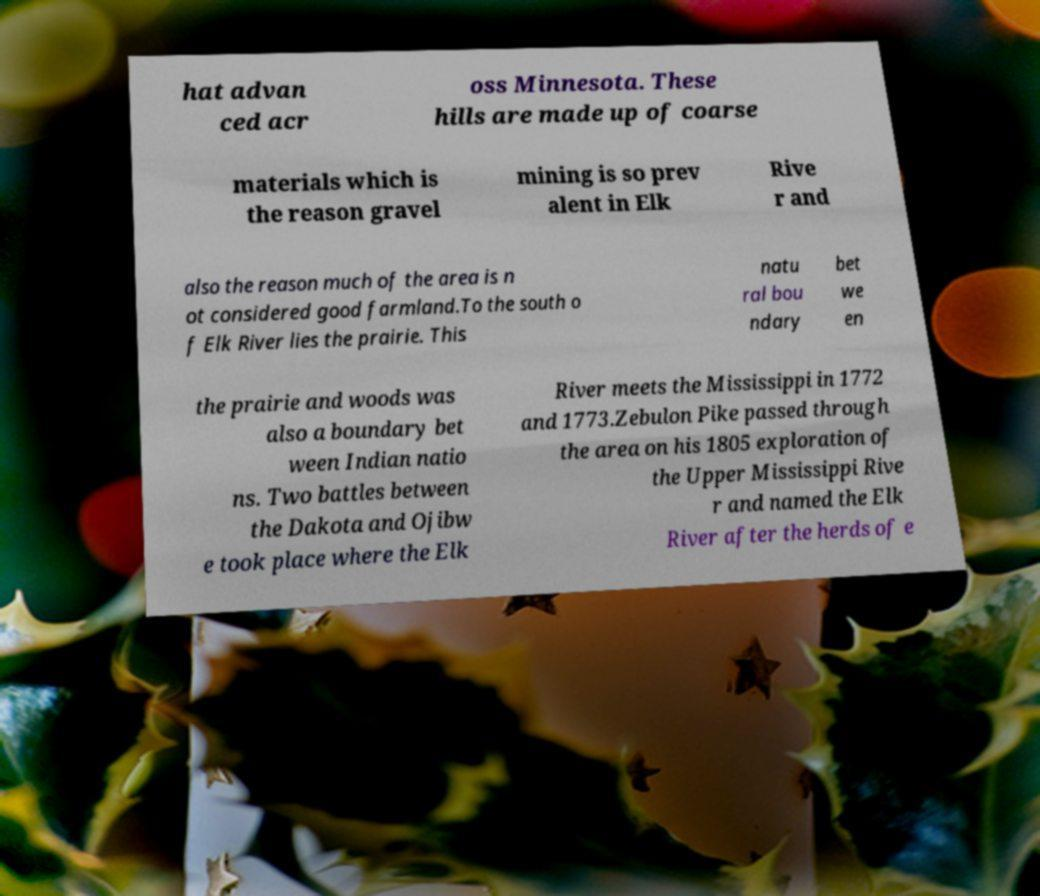Can you accurately transcribe the text from the provided image for me? hat advan ced acr oss Minnesota. These hills are made up of coarse materials which is the reason gravel mining is so prev alent in Elk Rive r and also the reason much of the area is n ot considered good farmland.To the south o f Elk River lies the prairie. This natu ral bou ndary bet we en the prairie and woods was also a boundary bet ween Indian natio ns. Two battles between the Dakota and Ojibw e took place where the Elk River meets the Mississippi in 1772 and 1773.Zebulon Pike passed through the area on his 1805 exploration of the Upper Mississippi Rive r and named the Elk River after the herds of e 